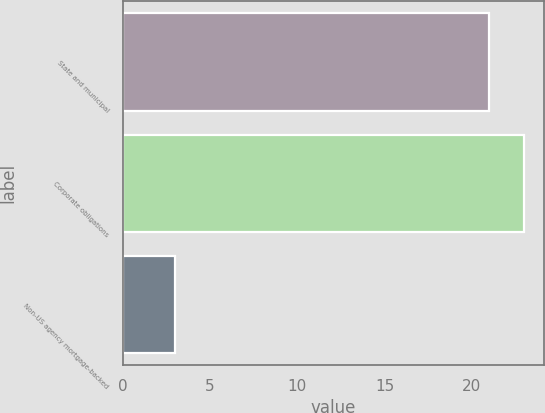<chart> <loc_0><loc_0><loc_500><loc_500><bar_chart><fcel>State and municipal<fcel>Corporate obligations<fcel>Non-US agency mortgage-backed<nl><fcel>21<fcel>23<fcel>3<nl></chart> 